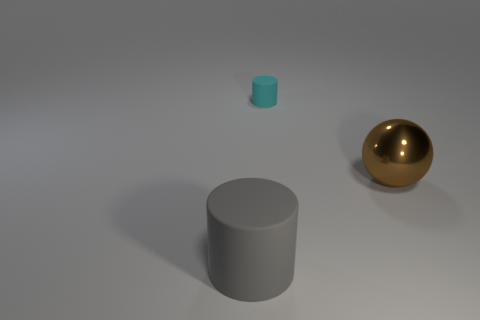Is there anything else that has the same shape as the large metal object?
Offer a terse response. No. Is the number of small matte things right of the brown metallic sphere the same as the number of big cylinders?
Offer a terse response. No. What number of balls are brown metallic things or gray things?
Ensure brevity in your answer.  1. Do the big metallic sphere and the tiny cylinder have the same color?
Ensure brevity in your answer.  No. Are there an equal number of small things on the right side of the cyan rubber cylinder and brown shiny things on the left side of the big brown metallic ball?
Provide a succinct answer. Yes. What color is the big rubber thing?
Keep it short and to the point. Gray. What number of things are objects behind the big ball or large yellow rubber objects?
Offer a very short reply. 1. Do the rubber thing that is behind the large gray matte cylinder and the ball on the right side of the gray matte object have the same size?
Your answer should be very brief. No. Are there any other things that are the same material as the brown thing?
Give a very brief answer. No. What number of things are matte cylinders left of the tiny matte cylinder or gray rubber cylinders in front of the brown sphere?
Your answer should be compact. 1. 